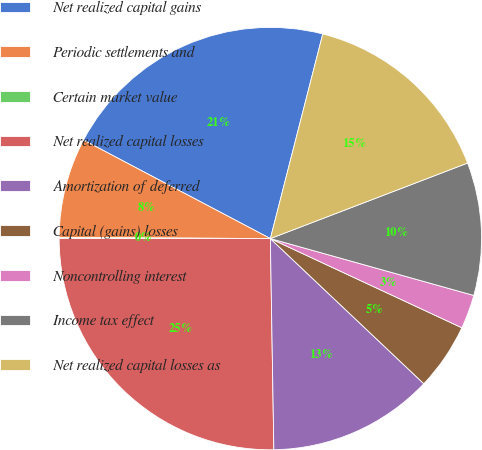<chart> <loc_0><loc_0><loc_500><loc_500><pie_chart><fcel>Net realized capital gains<fcel>Periodic settlements and<fcel>Certain market value<fcel>Net realized capital losses<fcel>Amortization of deferred<fcel>Capital (gains) losses<fcel>Noncontrolling interest<fcel>Income tax effect<fcel>Net realized capital losses as<nl><fcel>21.27%<fcel>7.64%<fcel>0.08%<fcel>25.27%<fcel>12.68%<fcel>5.12%<fcel>2.6%<fcel>10.16%<fcel>15.19%<nl></chart> 